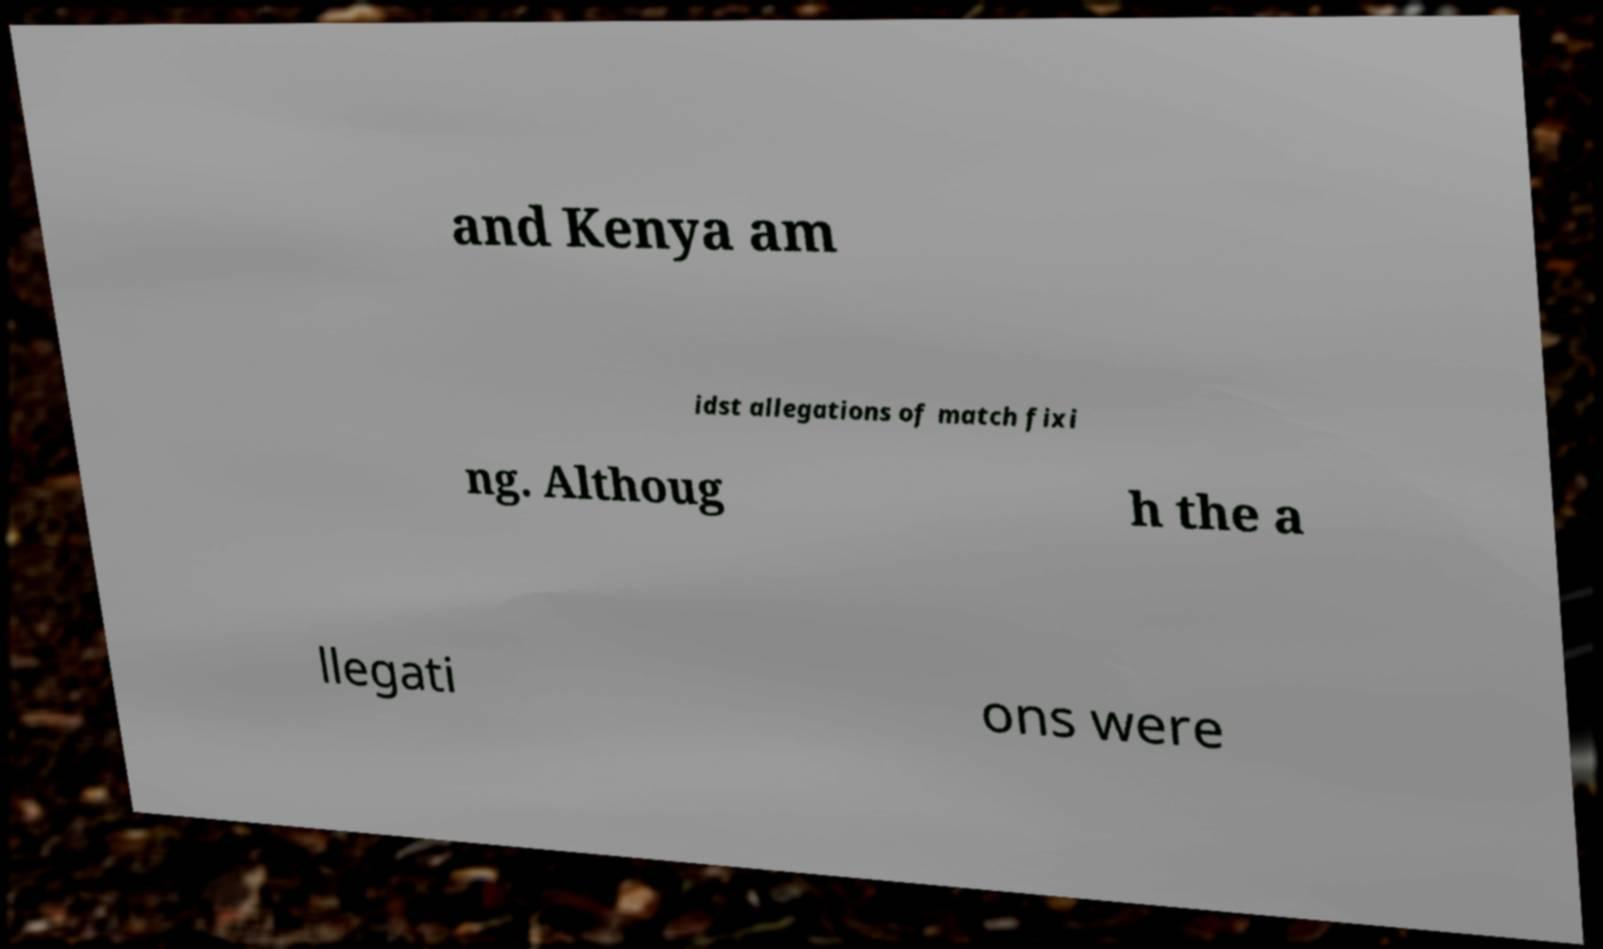What messages or text are displayed in this image? I need them in a readable, typed format. and Kenya am idst allegations of match fixi ng. Althoug h the a llegati ons were 